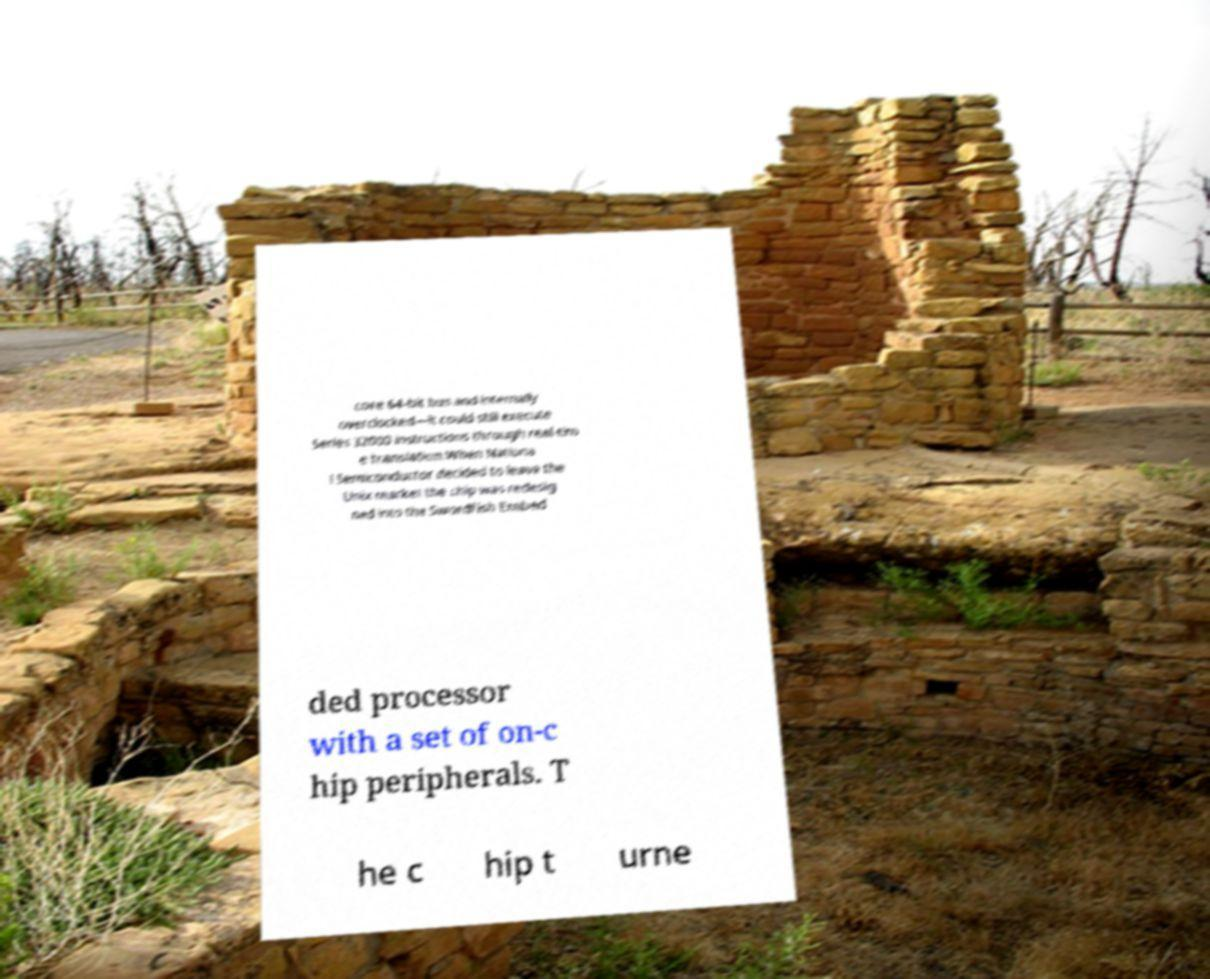Could you assist in decoding the text presented in this image and type it out clearly? core 64-bit bus and internally overclocked—it could still execute Series 32000 instructions through real-tim e translation.When Nationa l Semiconductor decided to leave the Unix market the chip was redesig ned into the Swordfish Embed ded processor with a set of on-c hip peripherals. T he c hip t urne 